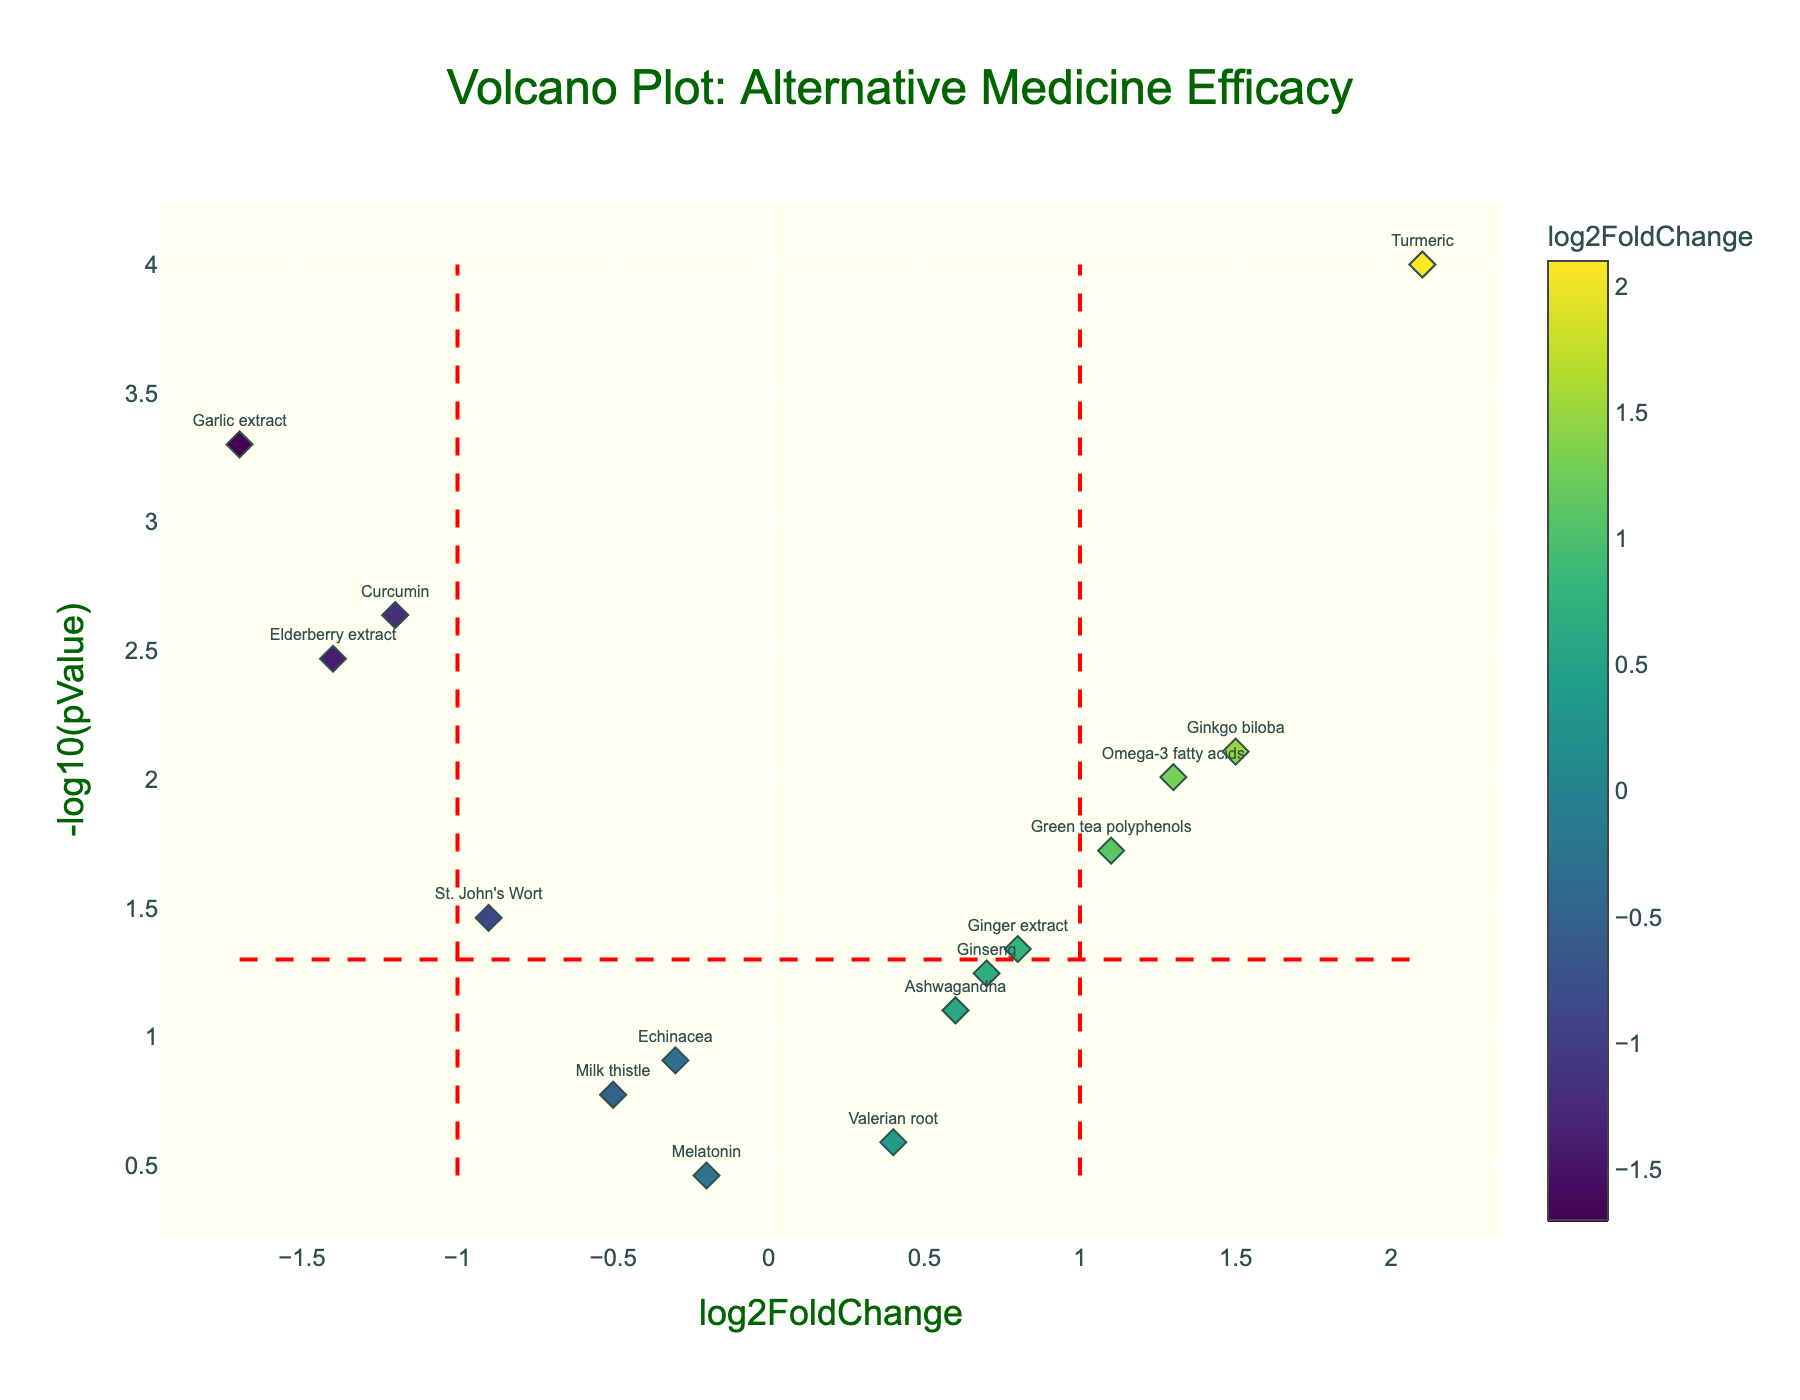What is the title of the figure? The title is located at the top center of the figure, displayed in large font and distinct color.
Answer: "Volcano Plot: Alternative Medicine Efficacy" How many proteins have a log2FoldChange greater than 1? Count the data points to the right of the vertical line at x=1. There are three data points (Ginkgo biloba, Turmeric, Omega-3 fatty acids).
Answer: 3 Which protein has the highest log2FoldChange? Look for the data point farthest to the right on the x-axis. Turmeric has the highest log2FoldChange.
Answer: Turmeric What is the approximate pValue for Garlic extract? Locate Garlic extract on the figure and check its position on the y-axis. Its y-value is approximately equivalent to -log10(0.0005).
Answer: 0.0005 Which proteins are considered statistically significant according to the horizontal red line at y=1.3? Find all the data points above the horizontal red dashed line (-log10(0.05) = 1.3): Curcumin, Ginkgo biloba, St. John's Wort, Garlic extract, Green tea polyphenols, Turmeric, Elderberry extract, and Omega-3 fatty acids.
Answer: 8 proteins What is the log2FoldChange range that contains most of the proteins? Visually assess the spread of data points along the x-axis. Most data points lie between -1.2 and 1.5 log2FoldChange.
Answer: -1.2 to 1.5 Which has a more significant negative log2FoldChange, Elderberry extract or Curcumin? Compare the positions of Elderberry extract and Curcumin on the x-axis. Elderberry extract (-1.4) is to the left of Curcumin (-1.2).
Answer: Elderberry extract Are there more upregulated or downregulated proteins in this study? Count data points to the right (upregulated) and left (downregulated) of the y-axis (x=0). There are more downregulated proteins.
Answer: More downregulated Is there any protein with a log2FoldChange close to zero but still statistically significant? Examine proteins with a log2FoldChange around zero and check if they are above the red dashed line. There are no such proteins close to zero that are statistically significant.
Answer: No What color represents low log2FoldChange values? Observe the color gradient on the volcano plot and the color bar. Darker colors represent lower log2FoldChange values.
Answer: Darker colors 